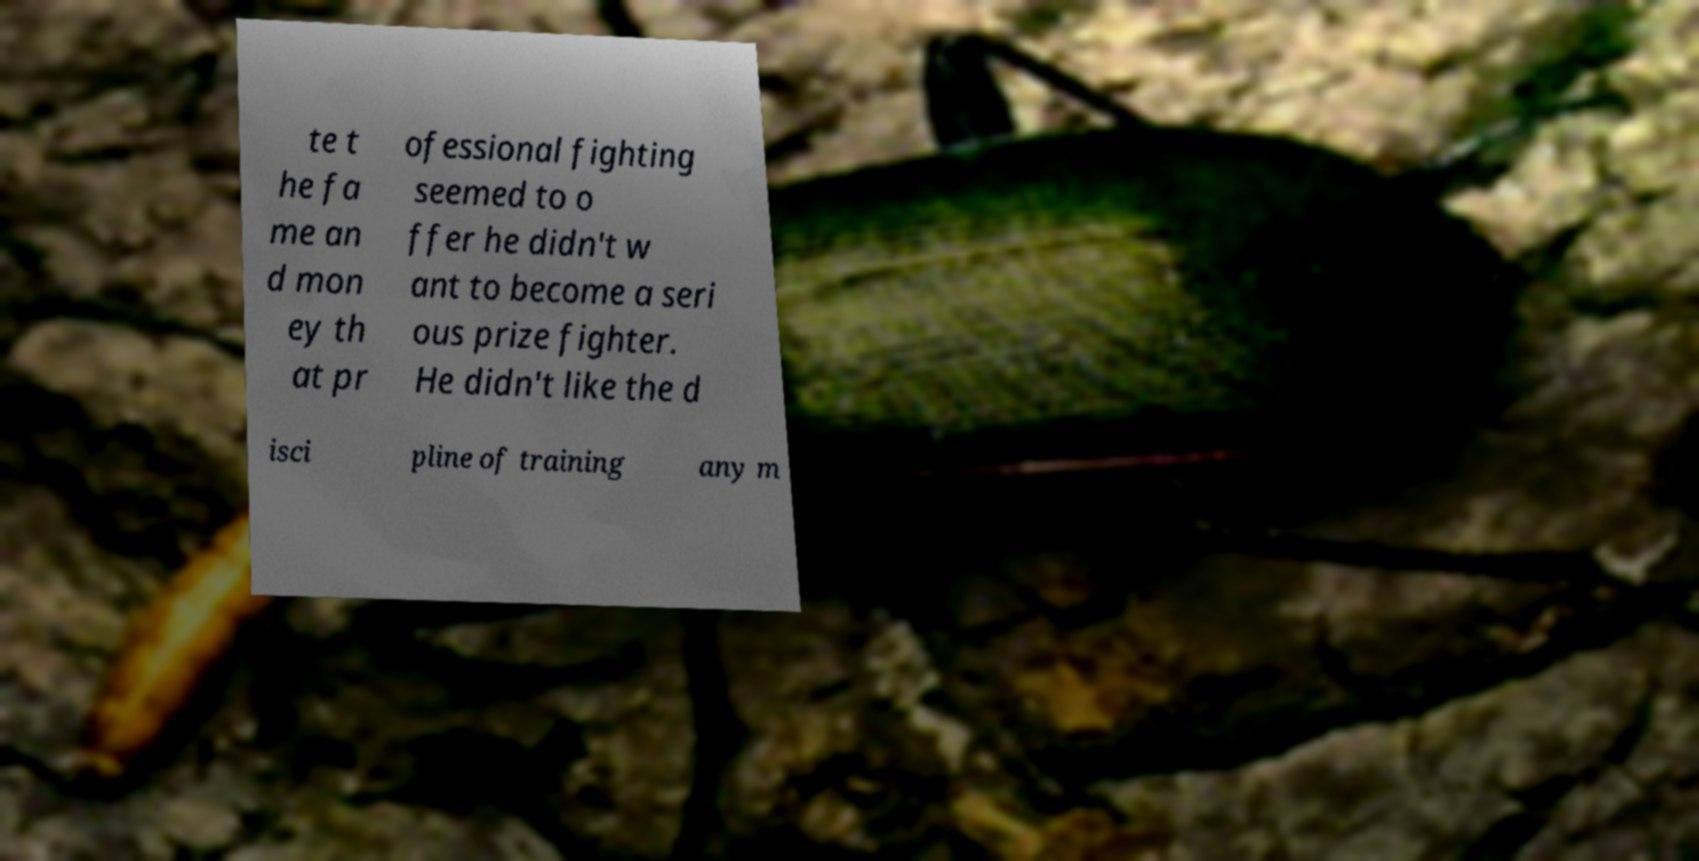Please read and relay the text visible in this image. What does it say? te t he fa me an d mon ey th at pr ofessional fighting seemed to o ffer he didn't w ant to become a seri ous prize fighter. He didn't like the d isci pline of training any m 